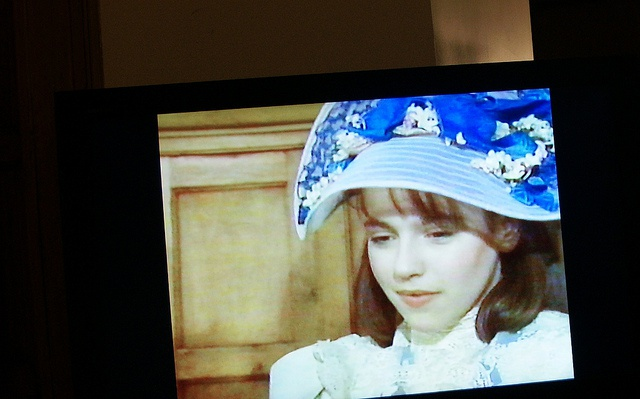Describe the objects in this image and their specific colors. I can see tv in black, lightblue, olive, and darkgray tones and people in black, lightblue, blue, and darkgray tones in this image. 